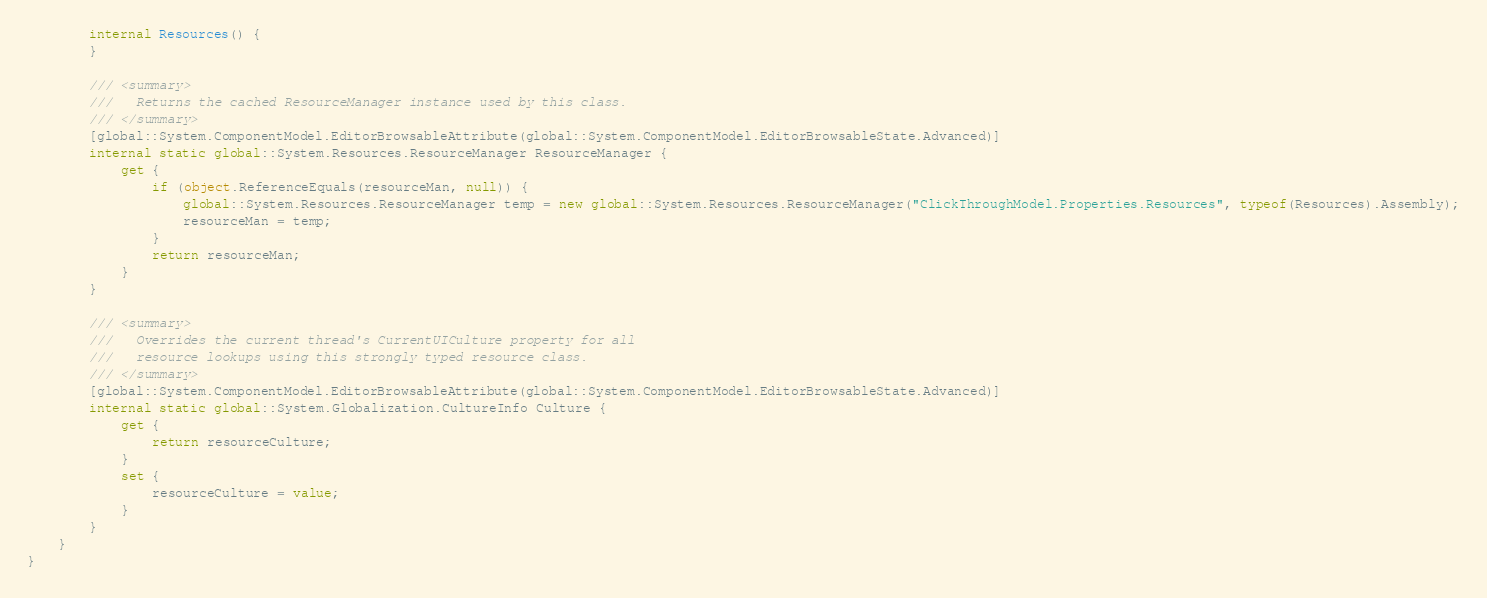Convert code to text. <code><loc_0><loc_0><loc_500><loc_500><_C#_>        internal Resources() {
        }
        
        /// <summary>
        ///   Returns the cached ResourceManager instance used by this class.
        /// </summary>
        [global::System.ComponentModel.EditorBrowsableAttribute(global::System.ComponentModel.EditorBrowsableState.Advanced)]
        internal static global::System.Resources.ResourceManager ResourceManager {
            get {
                if (object.ReferenceEquals(resourceMan, null)) {
                    global::System.Resources.ResourceManager temp = new global::System.Resources.ResourceManager("ClickThroughModel.Properties.Resources", typeof(Resources).Assembly);
                    resourceMan = temp;
                }
                return resourceMan;
            }
        }
        
        /// <summary>
        ///   Overrides the current thread's CurrentUICulture property for all
        ///   resource lookups using this strongly typed resource class.
        /// </summary>
        [global::System.ComponentModel.EditorBrowsableAttribute(global::System.ComponentModel.EditorBrowsableState.Advanced)]
        internal static global::System.Globalization.CultureInfo Culture {
            get {
                return resourceCulture;
            }
            set {
                resourceCulture = value;
            }
        }
    }
}
</code> 